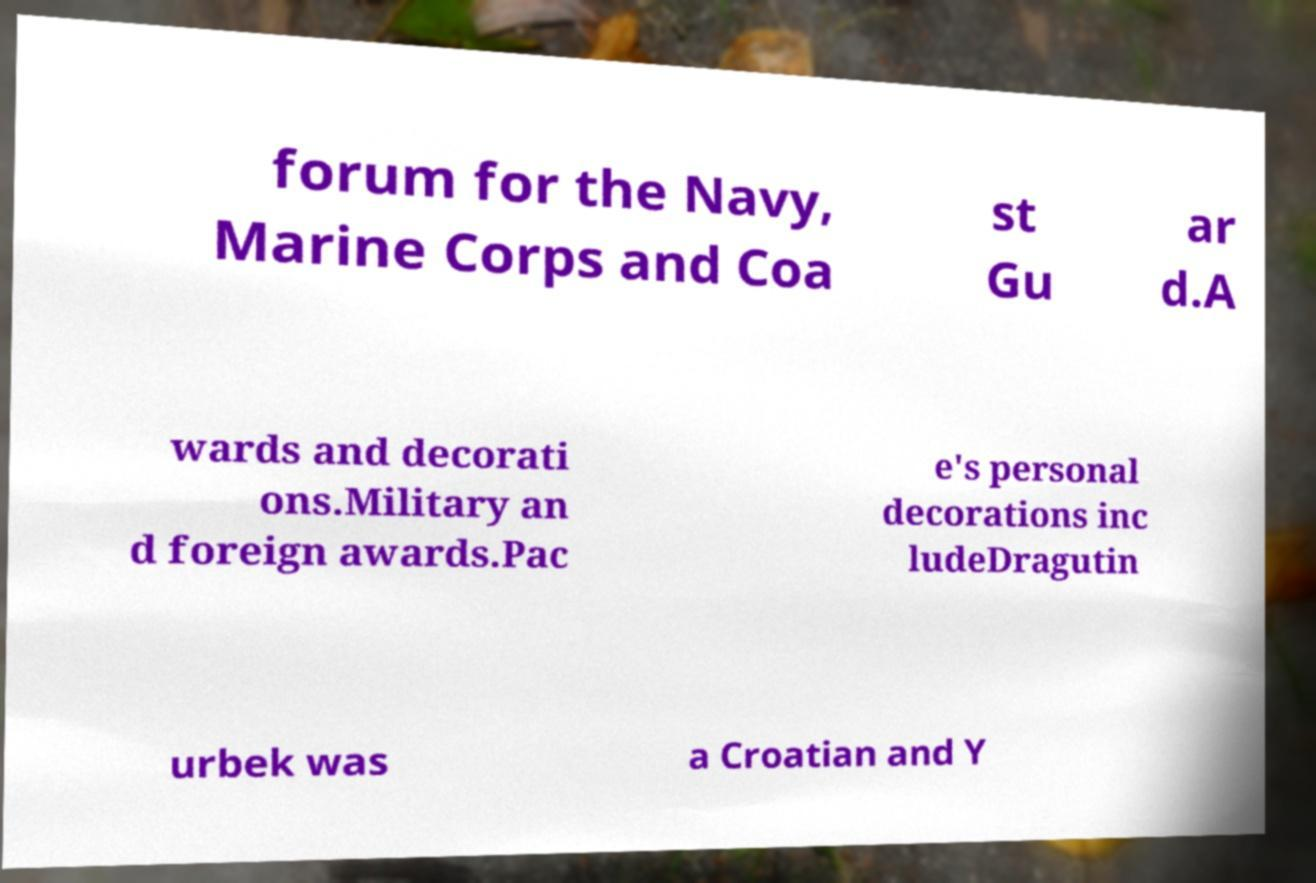Can you accurately transcribe the text from the provided image for me? forum for the Navy, Marine Corps and Coa st Gu ar d.A wards and decorati ons.Military an d foreign awards.Pac e's personal decorations inc ludeDragutin urbek was a Croatian and Y 